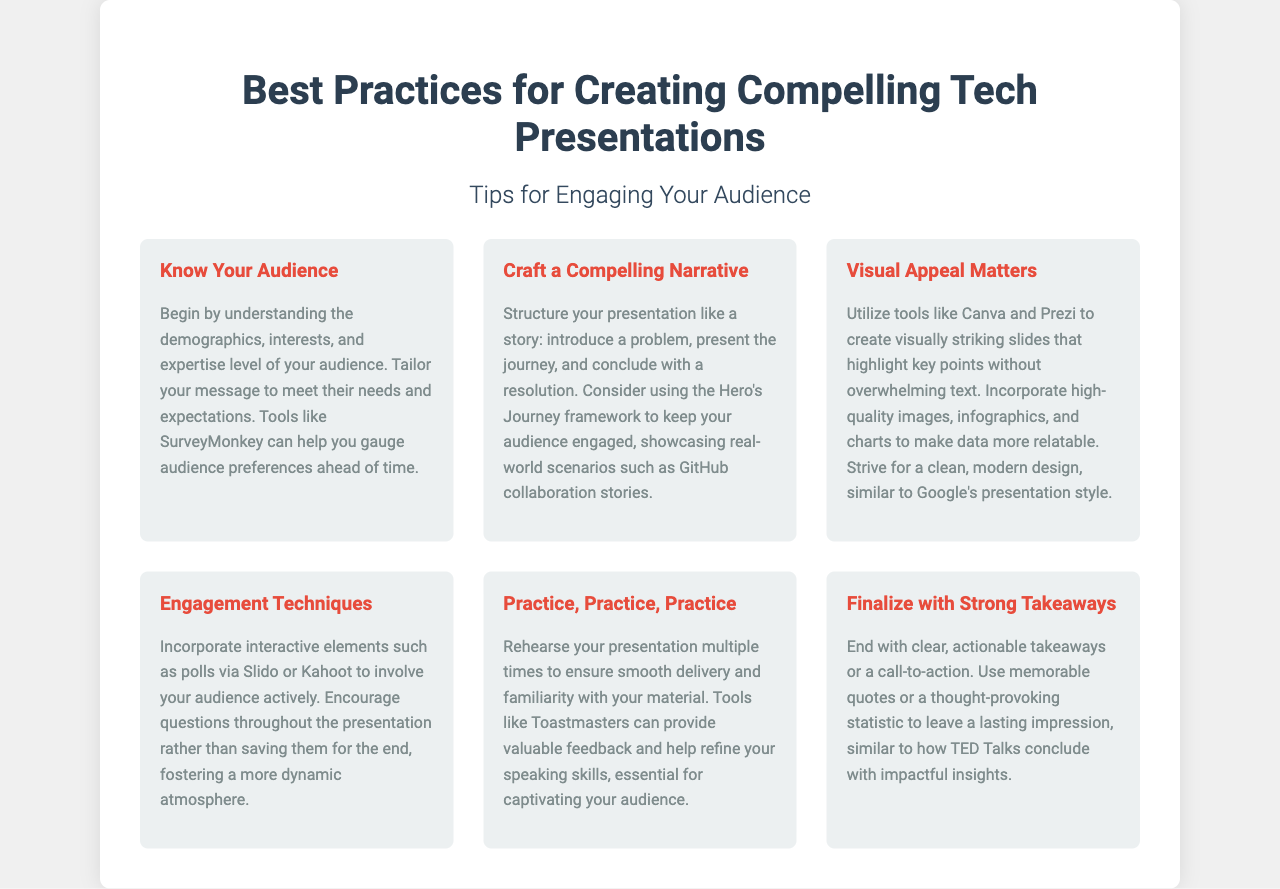What is the title of the document? The title is stated prominently at the top of the brochure.
Answer: Best Practices for Creating Compelling Tech Presentations Who is the intended audience for the presentation tips? The intended audience refers to the people for whom the presentation is tailored, as suggested in the first section.
Answer: Your Audience What is one tool suggested for gauging audience preferences? This information is found in the section about knowing your audience and mentions a specific tool.
Answer: SurveyMonkey What framework is recommended for structuring a narrative? The document refers to a specific narrative framework to maintain audience engagement.
Answer: Hero's Journey Which visual design tools are mentioned for creating slides? The brochure lists specific tools to enhance the visual appeal of presentations.
Answer: Canva and Prezi What is the last element to include in a presentation according to the document? This element is described in the final section of the brochure.
Answer: Strong Takeaways How should questions be handled during the presentation? This advice is given in the section about engagement techniques.
Answer: Encourage questions throughout Which speaking practice organization is mentioned? The document recommends an organization to improve speaking skills.
Answer: Toastmasters What color is used for the header text? The header text color is specifically indicated in the design section of the document.
Answer: #2c3e50 